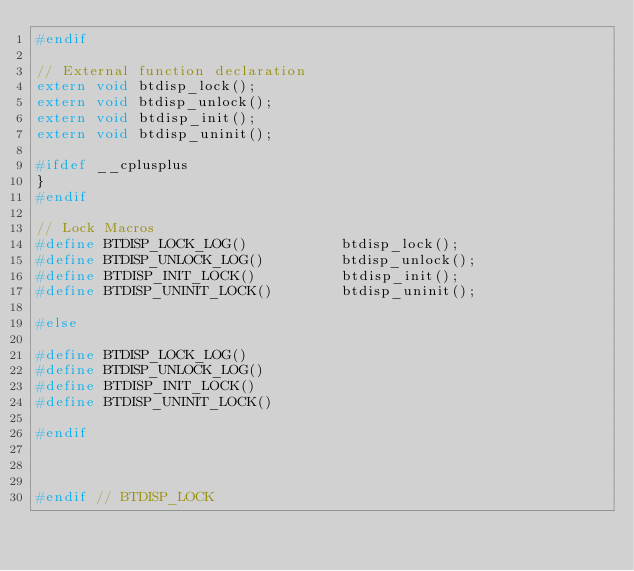Convert code to text. <code><loc_0><loc_0><loc_500><loc_500><_C_>#endif

// External function declaration
extern void btdisp_lock();
extern void btdisp_unlock();
extern void btdisp_init();
extern void btdisp_uninit();

#ifdef __cplusplus
}
#endif

// Lock Macros
#define BTDISP_LOCK_LOG()           btdisp_lock();
#define BTDISP_UNLOCK_LOG()         btdisp_unlock();
#define BTDISP_INIT_LOCK()          btdisp_init();
#define BTDISP_UNINIT_LOCK()        btdisp_uninit();

#else

#define BTDISP_LOCK_LOG()
#define BTDISP_UNLOCK_LOG()
#define BTDISP_INIT_LOCK()
#define BTDISP_UNINIT_LOCK()

#endif



#endif // BTDISP_LOCK</code> 